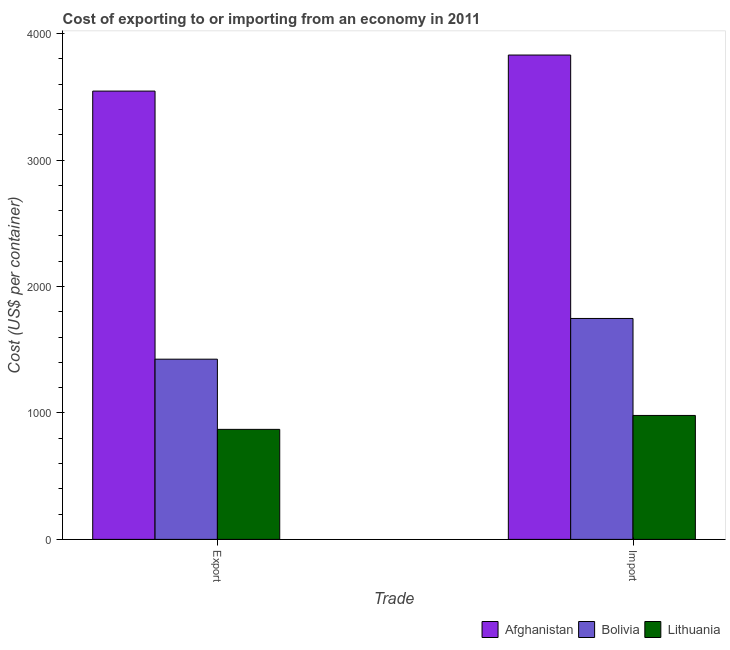How many different coloured bars are there?
Make the answer very short. 3. How many bars are there on the 1st tick from the left?
Your answer should be compact. 3. What is the label of the 1st group of bars from the left?
Offer a very short reply. Export. What is the import cost in Lithuania?
Provide a short and direct response. 980. Across all countries, what is the maximum export cost?
Give a very brief answer. 3545. Across all countries, what is the minimum import cost?
Make the answer very short. 980. In which country was the export cost maximum?
Give a very brief answer. Afghanistan. In which country was the export cost minimum?
Provide a short and direct response. Lithuania. What is the total export cost in the graph?
Keep it short and to the point. 5840. What is the difference between the export cost in Lithuania and that in Bolivia?
Keep it short and to the point. -555. What is the difference between the import cost in Bolivia and the export cost in Lithuania?
Offer a terse response. 877. What is the average export cost per country?
Your answer should be very brief. 1946.67. What is the difference between the export cost and import cost in Lithuania?
Your answer should be compact. -110. In how many countries, is the export cost greater than 2400 US$?
Ensure brevity in your answer.  1. What is the ratio of the export cost in Afghanistan to that in Bolivia?
Keep it short and to the point. 2.49. In how many countries, is the import cost greater than the average import cost taken over all countries?
Offer a very short reply. 1. What does the 3rd bar from the left in Import represents?
Provide a short and direct response. Lithuania. What does the 1st bar from the right in Export represents?
Offer a terse response. Lithuania. How many bars are there?
Provide a short and direct response. 6. Are all the bars in the graph horizontal?
Your answer should be very brief. No. Does the graph contain any zero values?
Provide a succinct answer. No. Does the graph contain grids?
Offer a very short reply. No. Where does the legend appear in the graph?
Ensure brevity in your answer.  Bottom right. How many legend labels are there?
Offer a very short reply. 3. What is the title of the graph?
Your answer should be compact. Cost of exporting to or importing from an economy in 2011. Does "Egypt, Arab Rep." appear as one of the legend labels in the graph?
Your response must be concise. No. What is the label or title of the X-axis?
Provide a short and direct response. Trade. What is the label or title of the Y-axis?
Provide a short and direct response. Cost (US$ per container). What is the Cost (US$ per container) in Afghanistan in Export?
Offer a very short reply. 3545. What is the Cost (US$ per container) of Bolivia in Export?
Ensure brevity in your answer.  1425. What is the Cost (US$ per container) of Lithuania in Export?
Provide a short and direct response. 870. What is the Cost (US$ per container) of Afghanistan in Import?
Offer a terse response. 3830. What is the Cost (US$ per container) of Bolivia in Import?
Your response must be concise. 1747. What is the Cost (US$ per container) of Lithuania in Import?
Your answer should be very brief. 980. Across all Trade, what is the maximum Cost (US$ per container) in Afghanistan?
Ensure brevity in your answer.  3830. Across all Trade, what is the maximum Cost (US$ per container) in Bolivia?
Keep it short and to the point. 1747. Across all Trade, what is the maximum Cost (US$ per container) in Lithuania?
Your answer should be compact. 980. Across all Trade, what is the minimum Cost (US$ per container) in Afghanistan?
Your response must be concise. 3545. Across all Trade, what is the minimum Cost (US$ per container) of Bolivia?
Make the answer very short. 1425. Across all Trade, what is the minimum Cost (US$ per container) in Lithuania?
Offer a very short reply. 870. What is the total Cost (US$ per container) of Afghanistan in the graph?
Give a very brief answer. 7375. What is the total Cost (US$ per container) in Bolivia in the graph?
Provide a short and direct response. 3172. What is the total Cost (US$ per container) of Lithuania in the graph?
Your answer should be very brief. 1850. What is the difference between the Cost (US$ per container) in Afghanistan in Export and that in Import?
Provide a short and direct response. -285. What is the difference between the Cost (US$ per container) of Bolivia in Export and that in Import?
Offer a terse response. -322. What is the difference between the Cost (US$ per container) of Lithuania in Export and that in Import?
Keep it short and to the point. -110. What is the difference between the Cost (US$ per container) in Afghanistan in Export and the Cost (US$ per container) in Bolivia in Import?
Your answer should be compact. 1798. What is the difference between the Cost (US$ per container) of Afghanistan in Export and the Cost (US$ per container) of Lithuania in Import?
Ensure brevity in your answer.  2565. What is the difference between the Cost (US$ per container) of Bolivia in Export and the Cost (US$ per container) of Lithuania in Import?
Your answer should be very brief. 445. What is the average Cost (US$ per container) in Afghanistan per Trade?
Ensure brevity in your answer.  3687.5. What is the average Cost (US$ per container) of Bolivia per Trade?
Offer a very short reply. 1586. What is the average Cost (US$ per container) in Lithuania per Trade?
Your answer should be very brief. 925. What is the difference between the Cost (US$ per container) of Afghanistan and Cost (US$ per container) of Bolivia in Export?
Give a very brief answer. 2120. What is the difference between the Cost (US$ per container) in Afghanistan and Cost (US$ per container) in Lithuania in Export?
Offer a very short reply. 2675. What is the difference between the Cost (US$ per container) in Bolivia and Cost (US$ per container) in Lithuania in Export?
Your response must be concise. 555. What is the difference between the Cost (US$ per container) in Afghanistan and Cost (US$ per container) in Bolivia in Import?
Offer a terse response. 2083. What is the difference between the Cost (US$ per container) of Afghanistan and Cost (US$ per container) of Lithuania in Import?
Provide a succinct answer. 2850. What is the difference between the Cost (US$ per container) of Bolivia and Cost (US$ per container) of Lithuania in Import?
Your answer should be very brief. 767. What is the ratio of the Cost (US$ per container) of Afghanistan in Export to that in Import?
Your response must be concise. 0.93. What is the ratio of the Cost (US$ per container) of Bolivia in Export to that in Import?
Your answer should be compact. 0.82. What is the ratio of the Cost (US$ per container) of Lithuania in Export to that in Import?
Provide a short and direct response. 0.89. What is the difference between the highest and the second highest Cost (US$ per container) of Afghanistan?
Provide a short and direct response. 285. What is the difference between the highest and the second highest Cost (US$ per container) of Bolivia?
Offer a very short reply. 322. What is the difference between the highest and the second highest Cost (US$ per container) of Lithuania?
Ensure brevity in your answer.  110. What is the difference between the highest and the lowest Cost (US$ per container) of Afghanistan?
Provide a succinct answer. 285. What is the difference between the highest and the lowest Cost (US$ per container) of Bolivia?
Offer a terse response. 322. What is the difference between the highest and the lowest Cost (US$ per container) of Lithuania?
Provide a short and direct response. 110. 